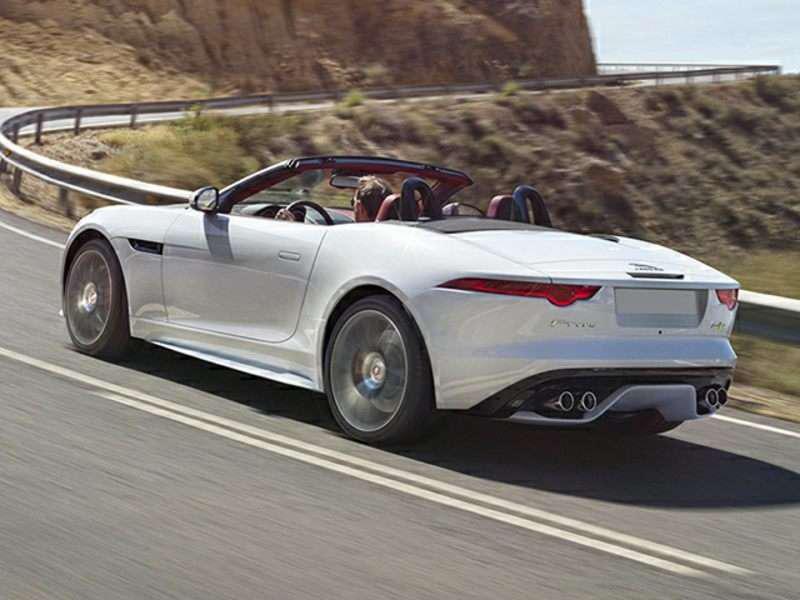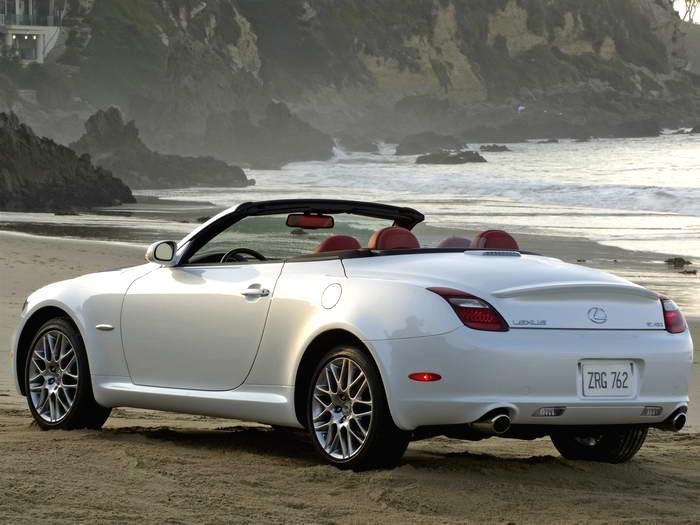The first image is the image on the left, the second image is the image on the right. Examine the images to the left and right. Is the description "An image shows a bright blue convertible with its top down." accurate? Answer yes or no. No. The first image is the image on the left, the second image is the image on the right. Examine the images to the left and right. Is the description "There is a blue car in the left image." accurate? Answer yes or no. No. 